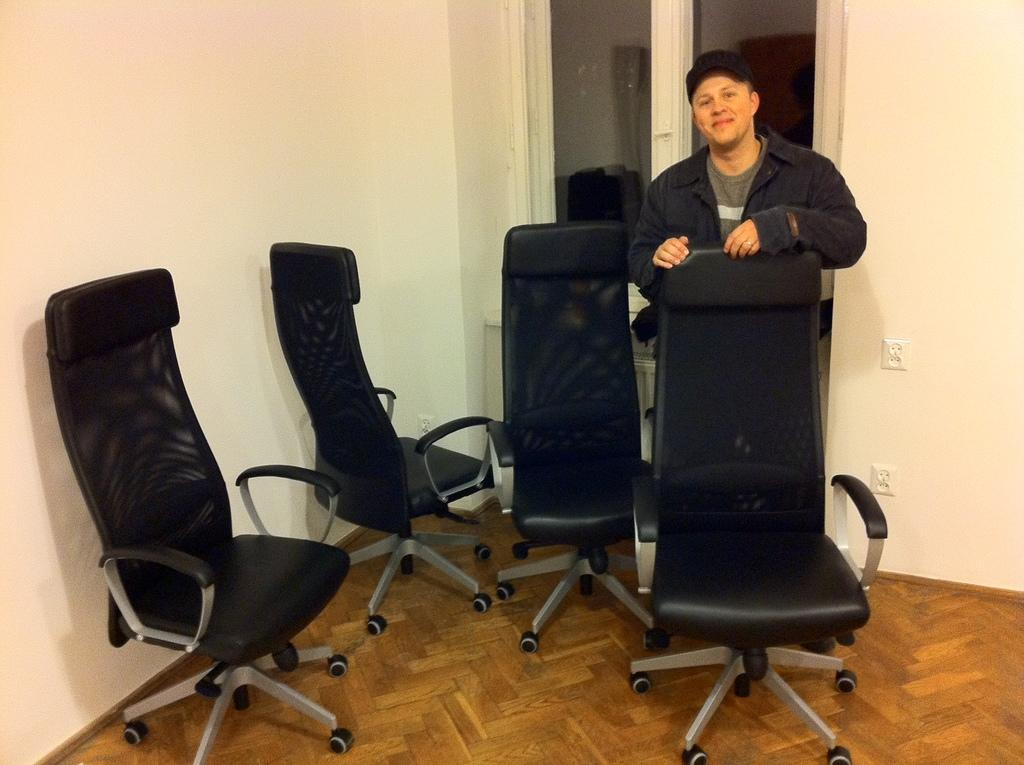What is the person in the image doing? The person is standing in front of a chair and smiling. How many chairs are visible in the image? There are additional chairs beside the person. What can be seen in the background of the image? There is a wall and a window in the background. What type of throne is the person sitting on in the image? There is no throne present in the image; the person is standing in front of a chair. Can you see any flames in the image? There are no flames visible in the image. 